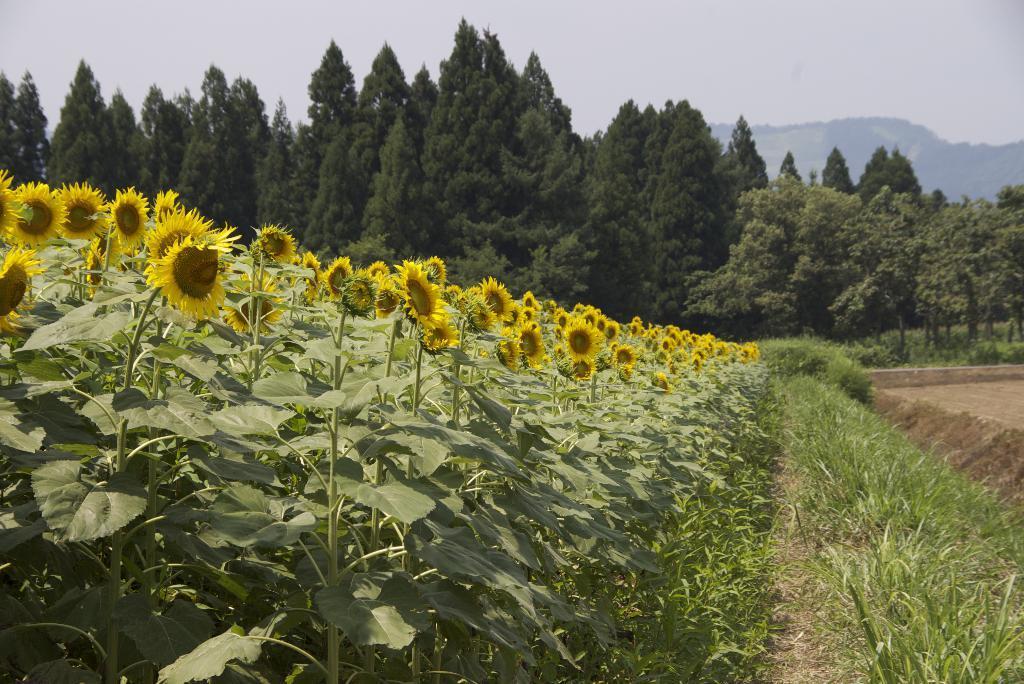Please provide a concise description of this image. These are the sunflower plants. This looks like the grass. In the background, I can see the trees with branches and leaves. This is the sky. 